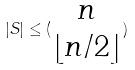Convert formula to latex. <formula><loc_0><loc_0><loc_500><loc_500>| S | \leq ( \begin{matrix} n \\ \lfloor n / 2 \rfloor \end{matrix} )</formula> 